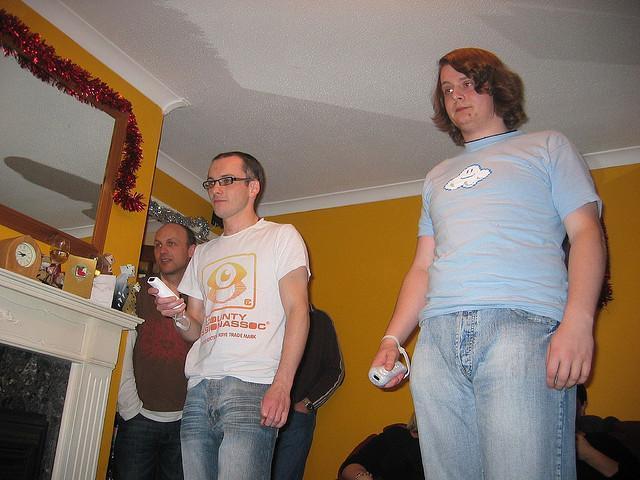How many people are there?
Give a very brief answer. 6. 